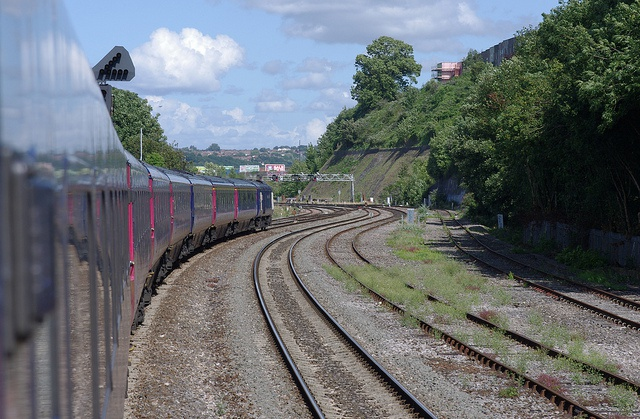Describe the objects in this image and their specific colors. I can see a train in darkgray, gray, and black tones in this image. 